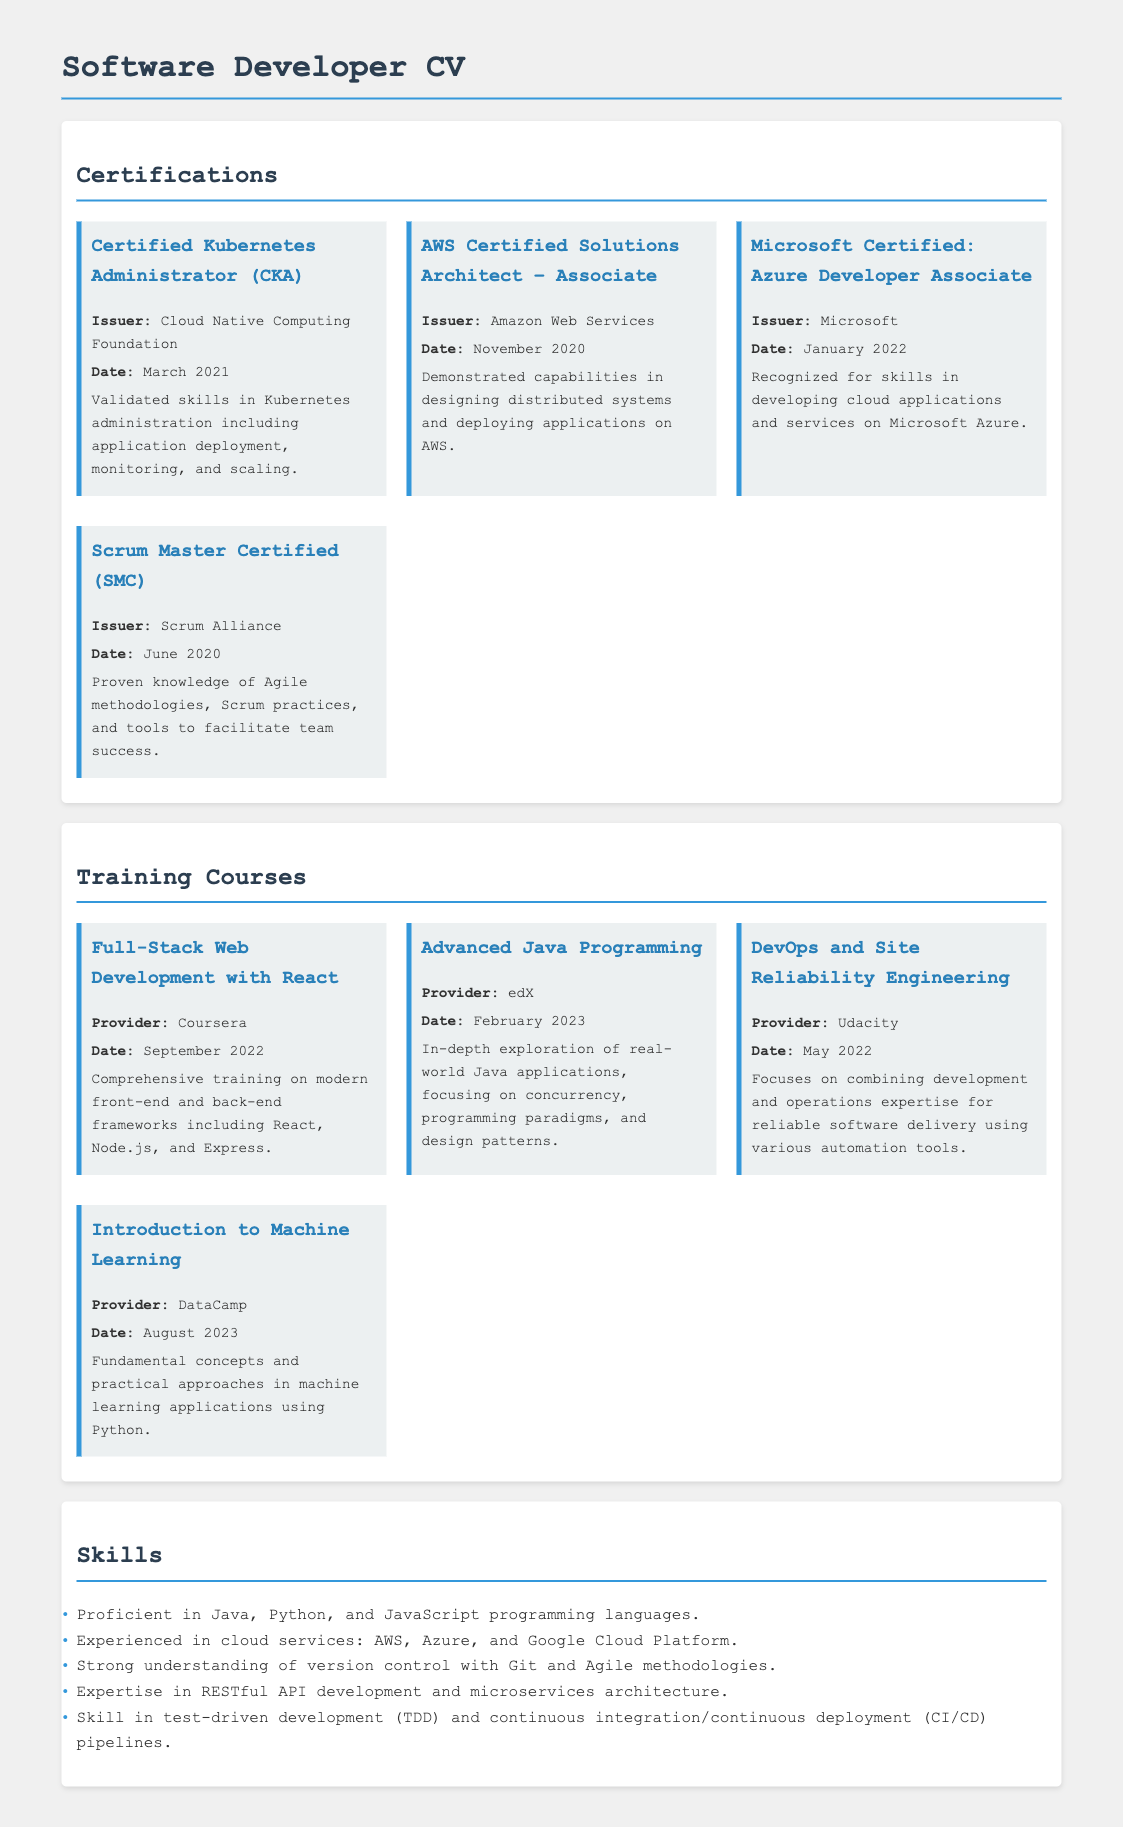What is the title of the first certification listed? The first certification listed is "Certified Kubernetes Administrator (CKA)."
Answer: Certified Kubernetes Administrator (CKA) Which organization issued the AWS Certified Solutions Architect certification? The document states that the AWS Certified Solutions Architect certification is issued by Amazon Web Services.
Answer: Amazon Web Services When did the Microsoft Certified: Azure Developer Associate certification get awarded? The date awarded is mentioned in the document as January 2022 for the Microsoft Certified: Azure Developer Associate certification.
Answer: January 2022 How many training courses are listed in the document? There are four training courses mentioned in the document under the Training Courses section.
Answer: Four Which programming languages are mentioned as proficient skills? The document lists Java, Python, and JavaScript as the proficient programming languages.
Answer: Java, Python, JavaScript What is the focus of the DevOps and Site Reliability Engineering course? The focus as stated is on combining development and operations expertise for reliable software delivery.
Answer: Combining development and operations expertise Which certification was awarded in June 2020? The certification that was awarded in June 2020 is the Scrum Master Certified (SMC).
Answer: Scrum Master Certified (SMC) What is the provider of the Full-Stack Web Development training course? The Full-Stack Web Development training course is provided by Coursera.
Answer: Coursera In what month and year did the Advanced Java Programming course occur? The month and year indicated for the Advanced Java Programming course is February 2023.
Answer: February 2023 What skill is emphasized in test-driven development mentioned in the Skills section? The document emphasizes continuous integration/continuous deployment (CI/CD) pipelines in relation to test-driven development (TDD).
Answer: Continuous integration/continuous deployment (CI/CD) pipelines 